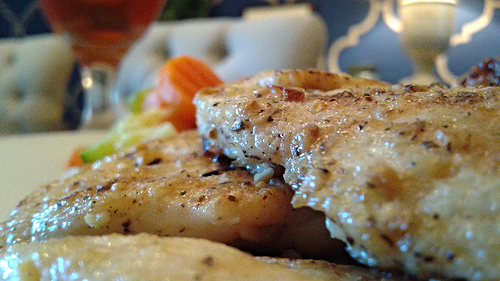<image>
Is the food behind the glass? Yes. From this viewpoint, the food is positioned behind the glass, with the glass partially or fully occluding the food. 